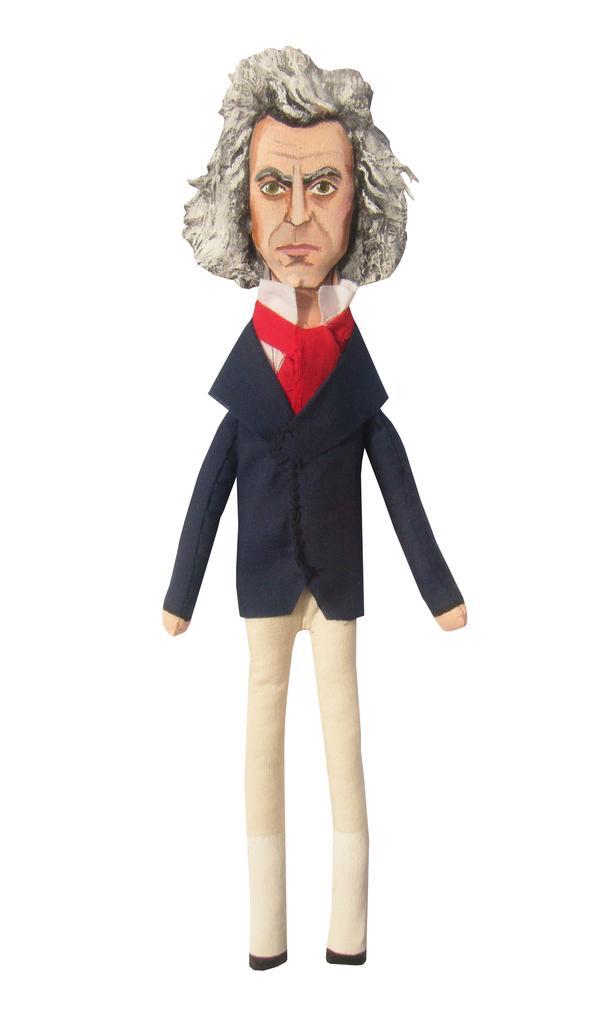Please provide a concise description of this image. In this picture we can see the toy of a person wearing a blue coat and a cream pant with short white hair. 